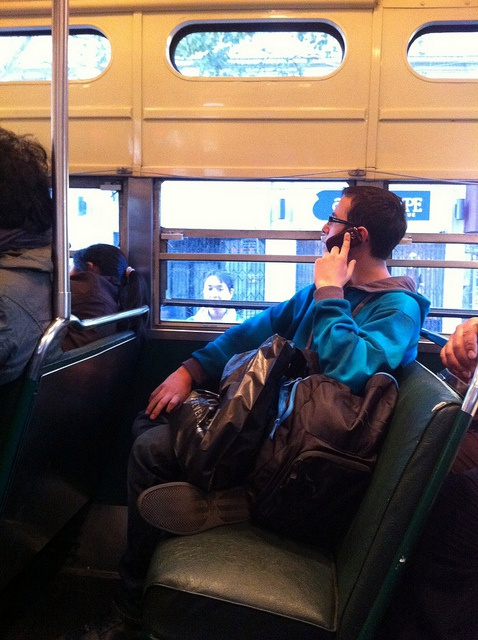Describe the objects in this image and their specific colors. I can see people in orange, black, navy, blue, and lightblue tones, backpack in orange, black, maroon, brown, and navy tones, handbag in orange, black, maroon, and gray tones, people in orange, black, gray, and maroon tones, and people in orange, black, navy, and purple tones in this image. 